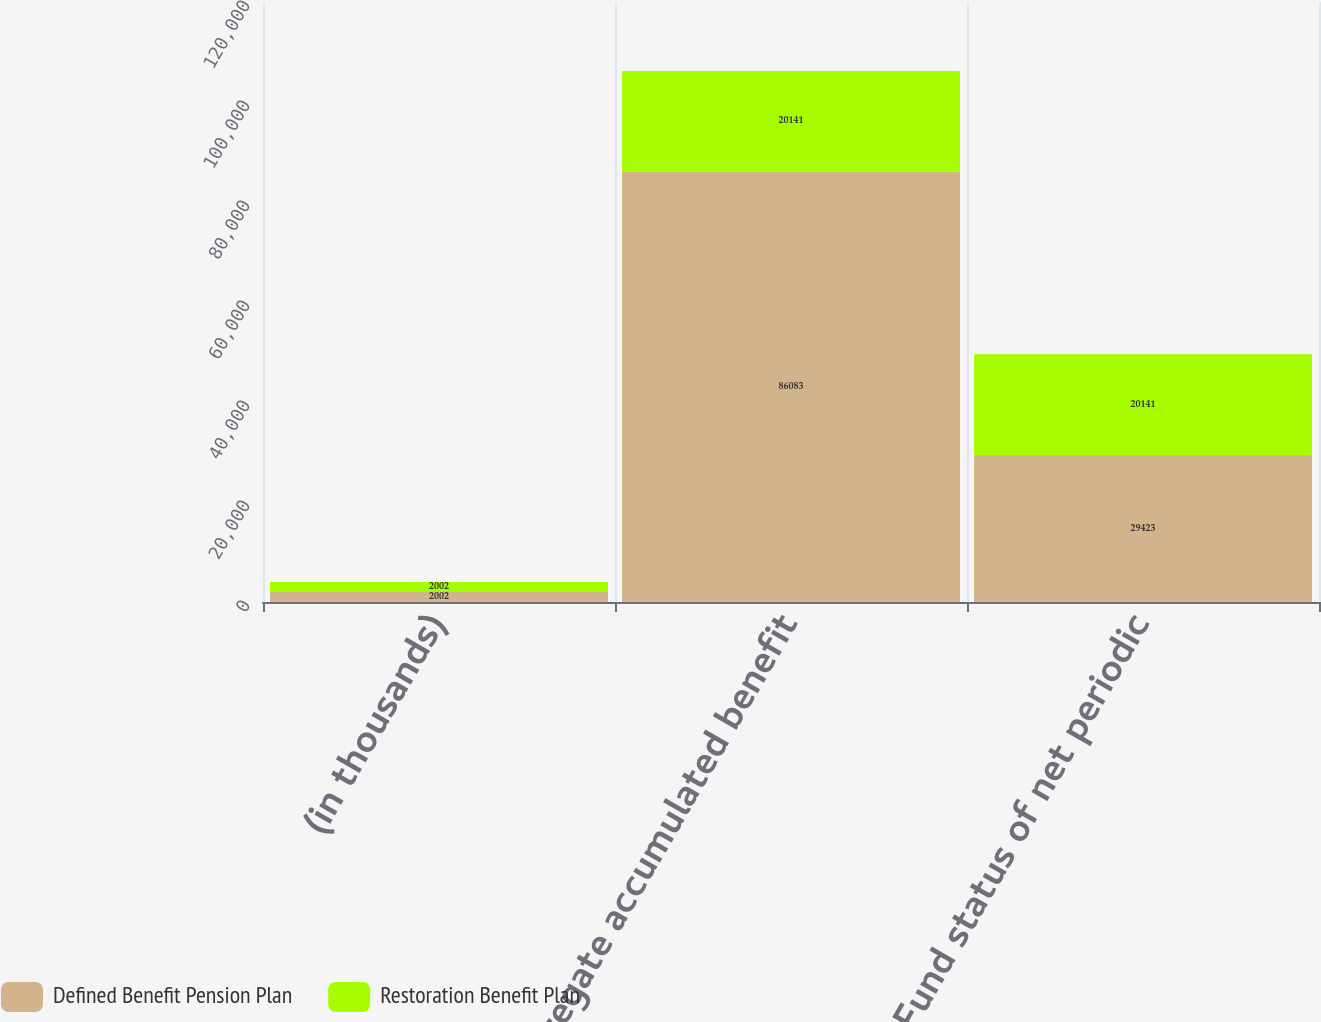Convert chart. <chart><loc_0><loc_0><loc_500><loc_500><stacked_bar_chart><ecel><fcel>(in thousands)<fcel>Aggregate accumulated benefit<fcel>Fund status of net periodic<nl><fcel>Defined Benefit Pension Plan<fcel>2002<fcel>86083<fcel>29423<nl><fcel>Restoration Benefit Plan<fcel>2002<fcel>20141<fcel>20141<nl></chart> 